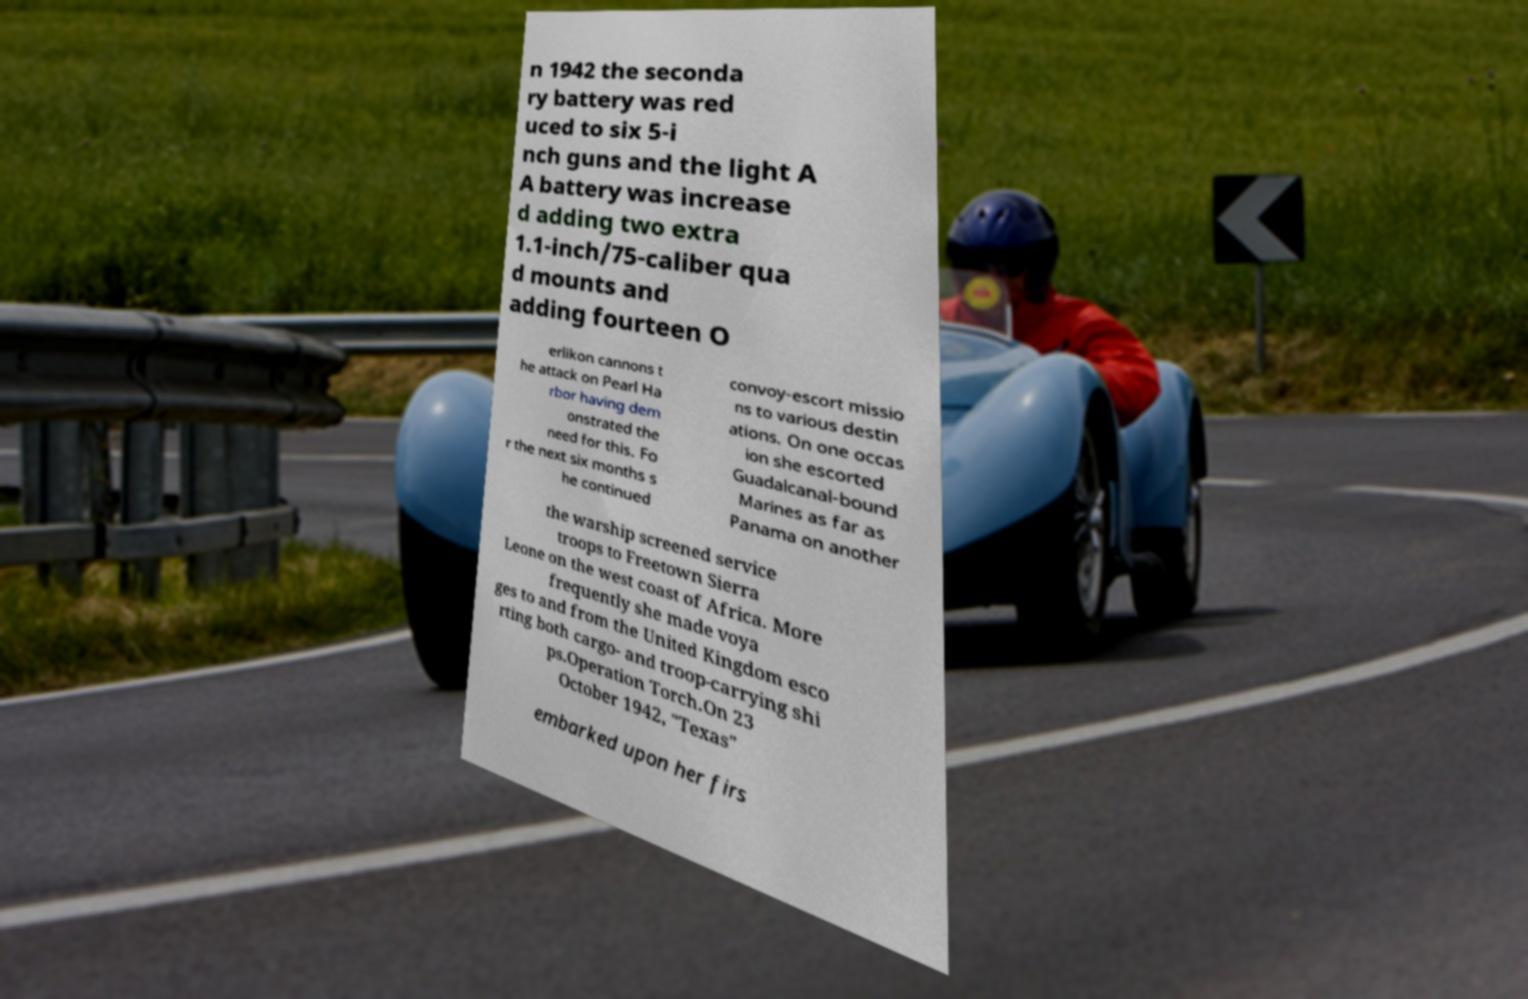Please read and relay the text visible in this image. What does it say? n 1942 the seconda ry battery was red uced to six 5-i nch guns and the light A A battery was increase d adding two extra 1.1-inch/75-caliber qua d mounts and adding fourteen O erlikon cannons t he attack on Pearl Ha rbor having dem onstrated the need for this. Fo r the next six months s he continued convoy-escort missio ns to various destin ations. On one occas ion she escorted Guadalcanal-bound Marines as far as Panama on another the warship screened service troops to Freetown Sierra Leone on the west coast of Africa. More frequently she made voya ges to and from the United Kingdom esco rting both cargo- and troop-carrying shi ps.Operation Torch.On 23 October 1942, "Texas" embarked upon her firs 